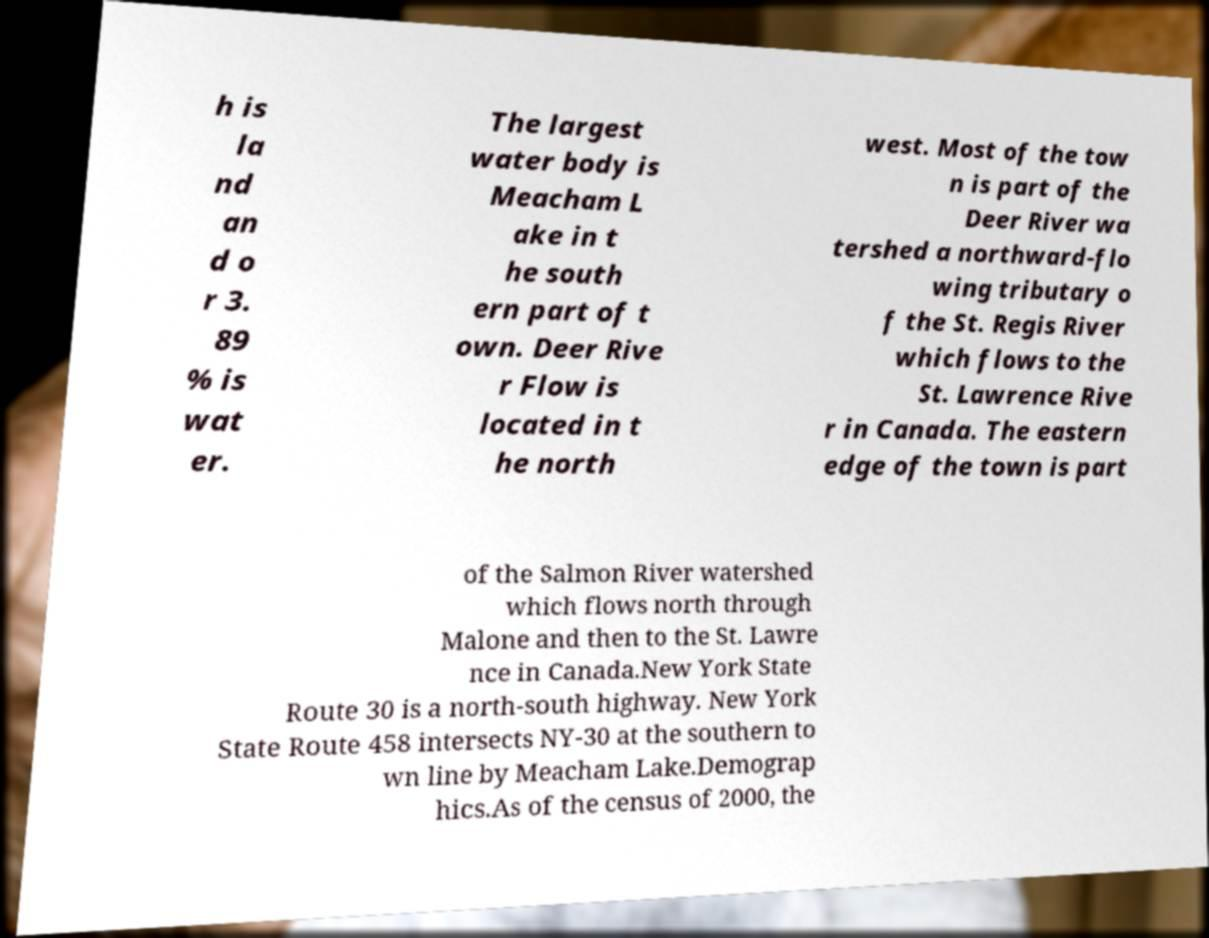There's text embedded in this image that I need extracted. Can you transcribe it verbatim? h is la nd an d o r 3. 89 % is wat er. The largest water body is Meacham L ake in t he south ern part of t own. Deer Rive r Flow is located in t he north west. Most of the tow n is part of the Deer River wa tershed a northward-flo wing tributary o f the St. Regis River which flows to the St. Lawrence Rive r in Canada. The eastern edge of the town is part of the Salmon River watershed which flows north through Malone and then to the St. Lawre nce in Canada.New York State Route 30 is a north-south highway. New York State Route 458 intersects NY-30 at the southern to wn line by Meacham Lake.Demograp hics.As of the census of 2000, the 